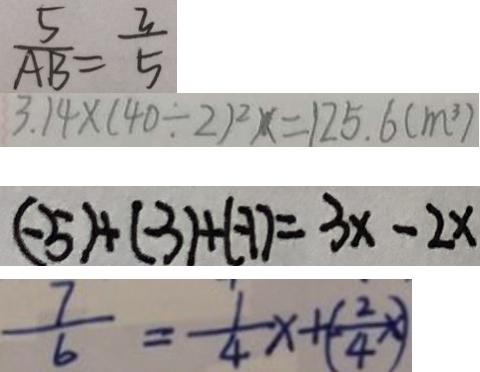<formula> <loc_0><loc_0><loc_500><loc_500>\frac { 5 } { A B } = \frac { 3 } { 5 } 
 3 . 1 4 \times ( 4 0 \div 2 ) ^ { 2 } x = 1 2 5 . 6 ( m ^ { 3 } ) 
 ( - 5 ) + ( - 3 ) + ( - 1 ) = 3 x - 2 x 
 \frac { 7 } { 6 } = \frac { 1 } { 4 } x + ( - \frac { 2 } { 4 } x )</formula> 